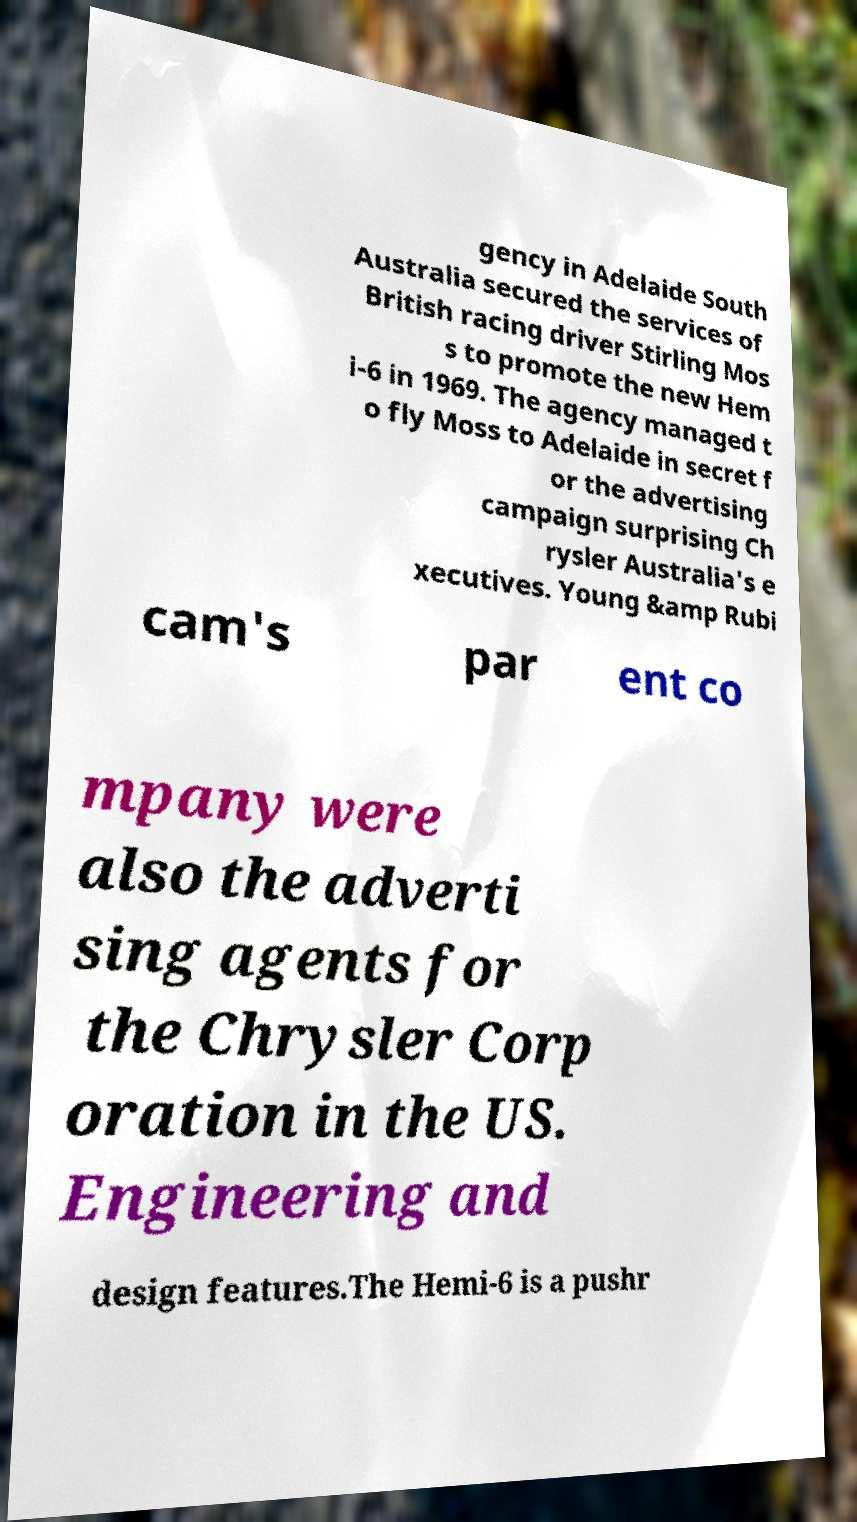Could you extract and type out the text from this image? gency in Adelaide South Australia secured the services of British racing driver Stirling Mos s to promote the new Hem i-6 in 1969. The agency managed t o fly Moss to Adelaide in secret f or the advertising campaign surprising Ch rysler Australia's e xecutives. Young &amp Rubi cam's par ent co mpany were also the adverti sing agents for the Chrysler Corp oration in the US. Engineering and design features.The Hemi-6 is a pushr 